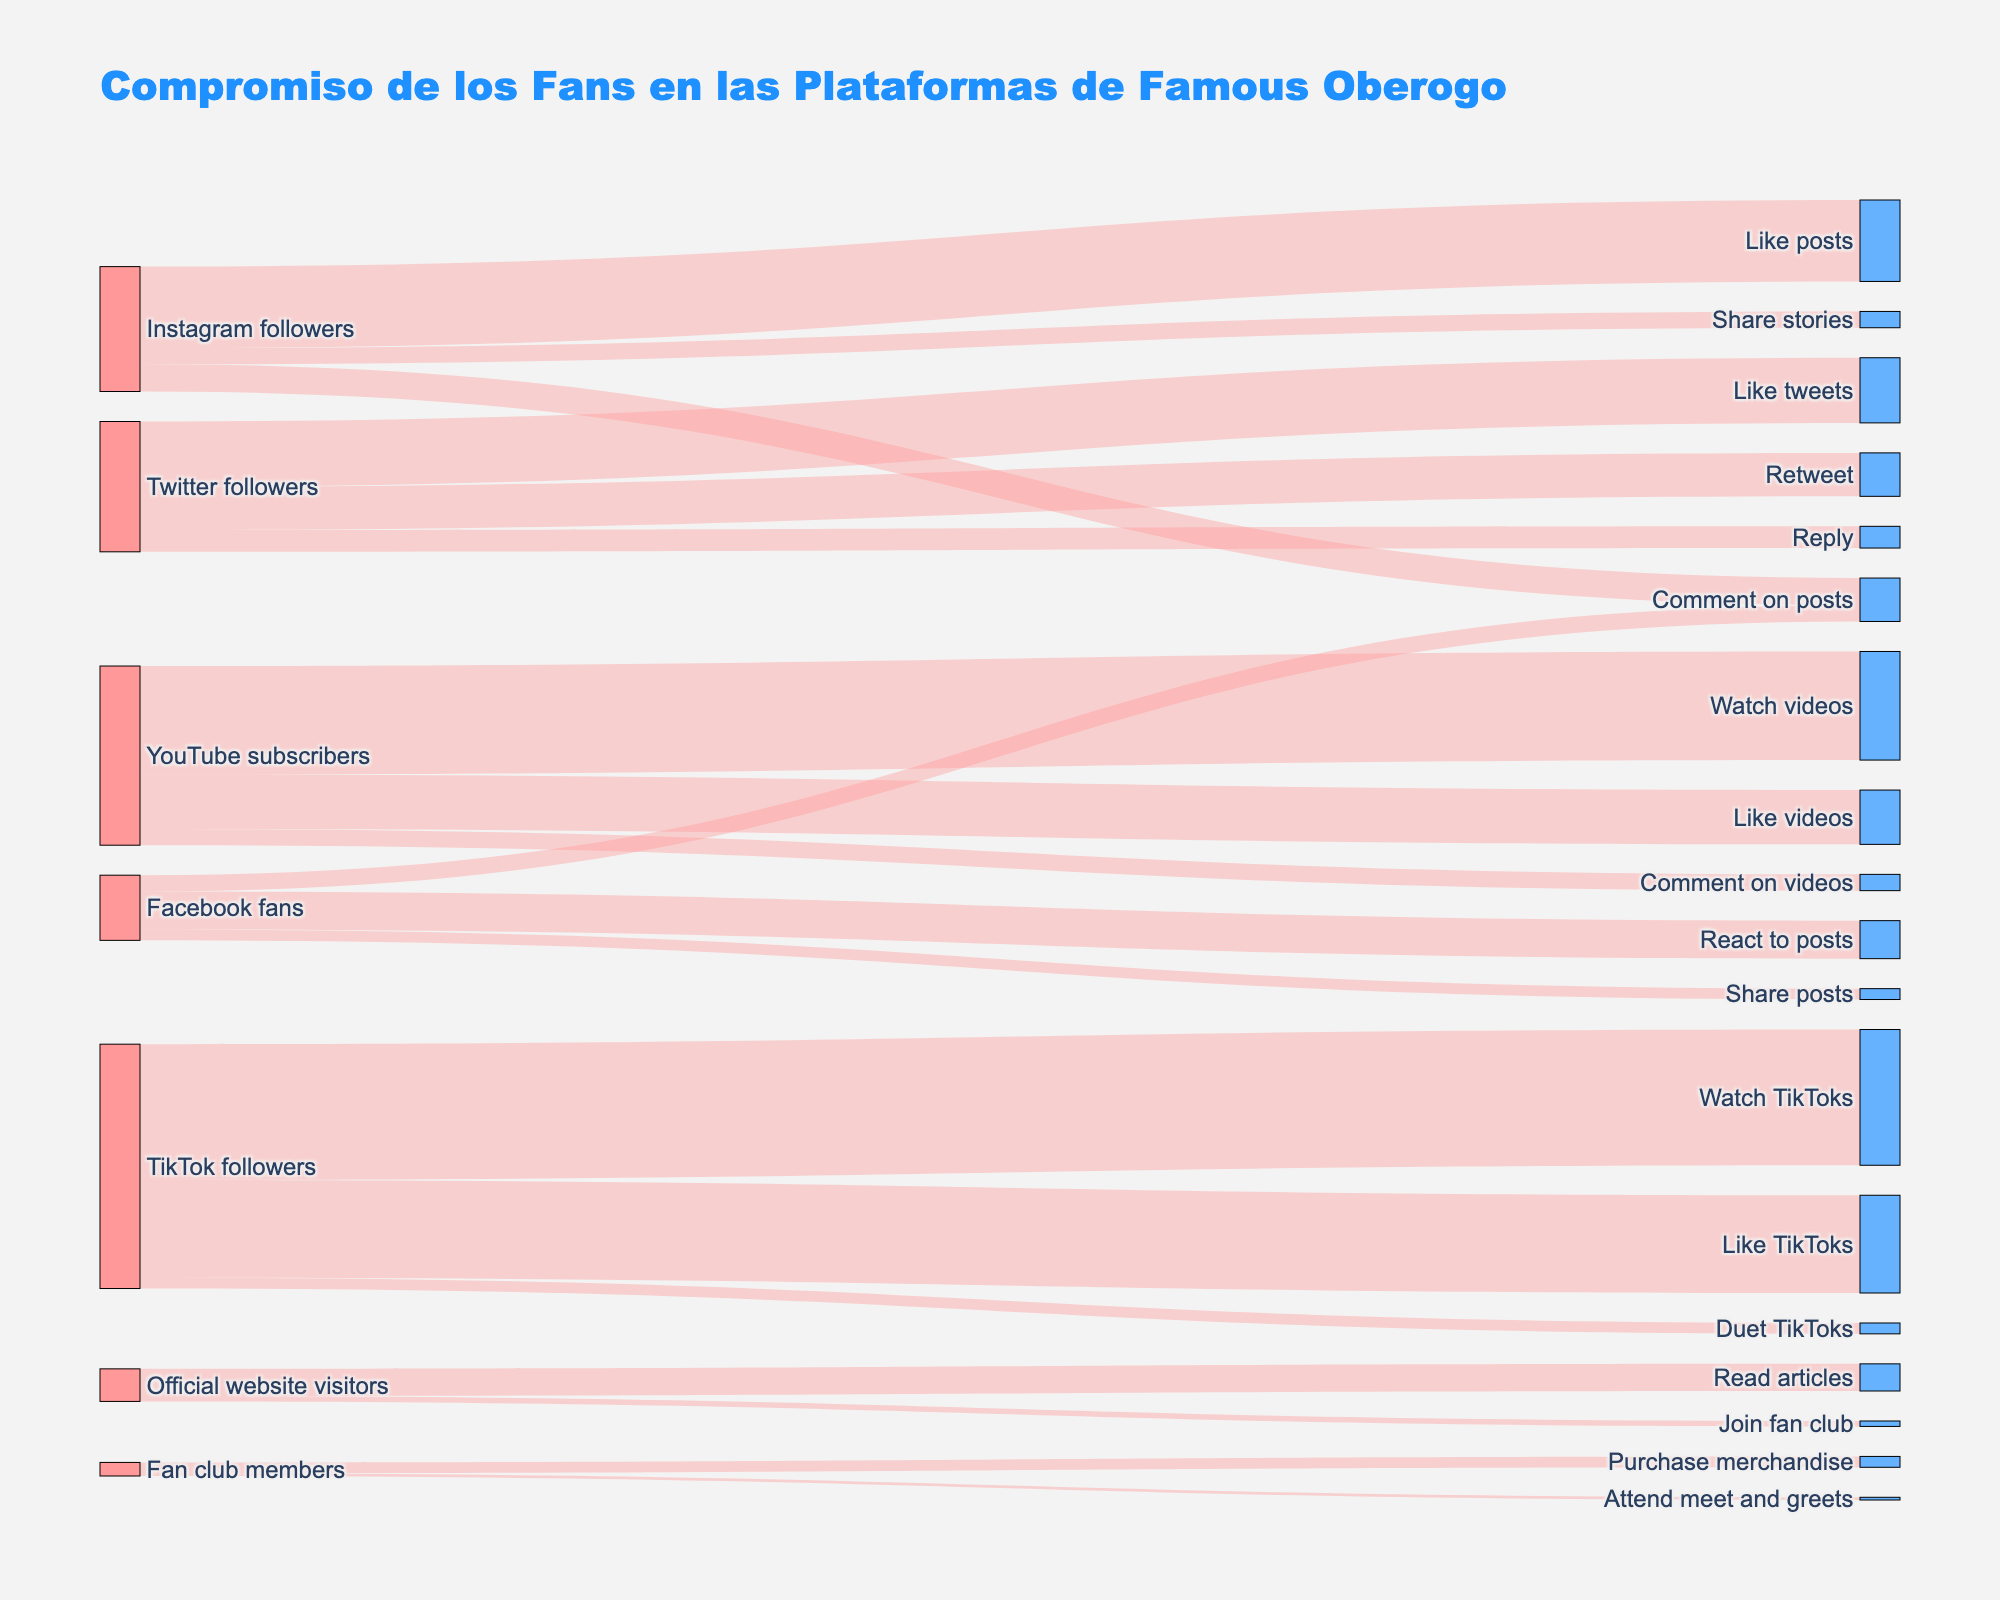¿Cuál es el título del diagrama Sankey? El título se encuentra en la parte superior del diagrama y está escrito en texto grande y destacado. En este caso, el título dice "Compromiso de los Fans en las Plataformas de Famous Oberogo".
Answer: Compromiso de los Fans en las Plataformas de Famous Oberogo ¿Cuántos fanáticos siguen a Famous Oberogo en TikTok? Uno de los nodos indica "TikTok followers" y el tamaño del flujo hacia otros nodos puede ayudarnos a deducir el número. Tenemos tres flujos hacia diferentes actividades: 25,000 viendo TikToks, 18,000 dando "Likes" y 2,000 haciendo dúos.
Answer: 25000 ¿Qué actividad tiene más participación entre los suscriptores de YouTube de Famous Oberogo? En los nodos que parten de "YouTube subscribers", hay tres actividades: "Watch videos" con 20,000, "Like videos" con 10,000 y "Comment on videos" con 3,000. Comparando estos valores, "Watch videos" tiene la mayor cantidad.
Answer: Watch videos ¿Cuántos fanáticos de Instagram comentan en las publicaciones? Buscando el nodo "Instagram followers" y los flujos que van hacia "Comment on posts", se observa que hay un flujo de 5,000.
Answer: 5000 ¿Cuál es la suma total de actividades realizadas por los seguidores de Twitter? Sumamos los valores asociados a las actividades de los "Twitter followers", que son 12,000 para "Like tweets", 8,000 para "Retweet" y 4,000 para "Reply". La suma es 12,000 + 8,000 + 4,000.
Answer: 24000 ¿Cuál plataforma tiene el mayor número de seguidores que participan en alguna actividad? Se observa cada nodo de plataformas y se suman las salidas. Por ejemplo, TikTok tiene 25,000 viendo videos, 18,000 dando "Likes", y 2,000 haciendo dúos. Comparando con otras plataformas, TikTok tiene la mayor participación en suma.
Answer: TikTok ¿Cuántos miembros del club de fans asisten a meet and greets? Mirando el flujo que sale del nodo "Fan club members" hacia el nodo "Attend meet and greets", observamos que el valor es 500.
Answer: 500 ¿Cuál es la diferencia en la cantidad de videos vistos entre los suscriptores de YouTube y los seguidores de TikTok? Comparando los flujos hacia "Watch videos" para YouTube (20,000) y "Watch TikToks" para TikTok (25,000), la diferencia es 25,000 - 20,000.
Answer: 5000 ¿Qué actividad realizada por los seguidores de Facebook tiene la menor participación? Del nodo "Facebook fans" salen tres flujos hacia distintas actividades: "React to posts" (7,000), "Share posts" (2,000) y "Comment on posts" (3,000). El flujo menor es el de "Share posts".
Answer: Share posts ¿Cuántos de los visitantes oficiales del sitio web de Famous Oberogo se unen al club de fans? Observando el flujo desde el nodo "Official website visitors" hacia "Join fan club", el valor es de 1,000.
Answer: 1000 